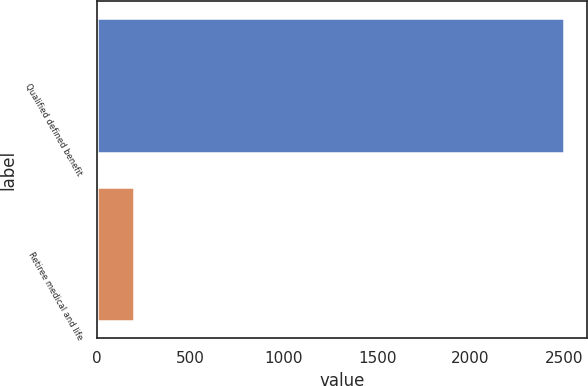Convert chart. <chart><loc_0><loc_0><loc_500><loc_500><bar_chart><fcel>Qualified defined benefit<fcel>Retiree medical and life<nl><fcel>2500<fcel>200<nl></chart> 